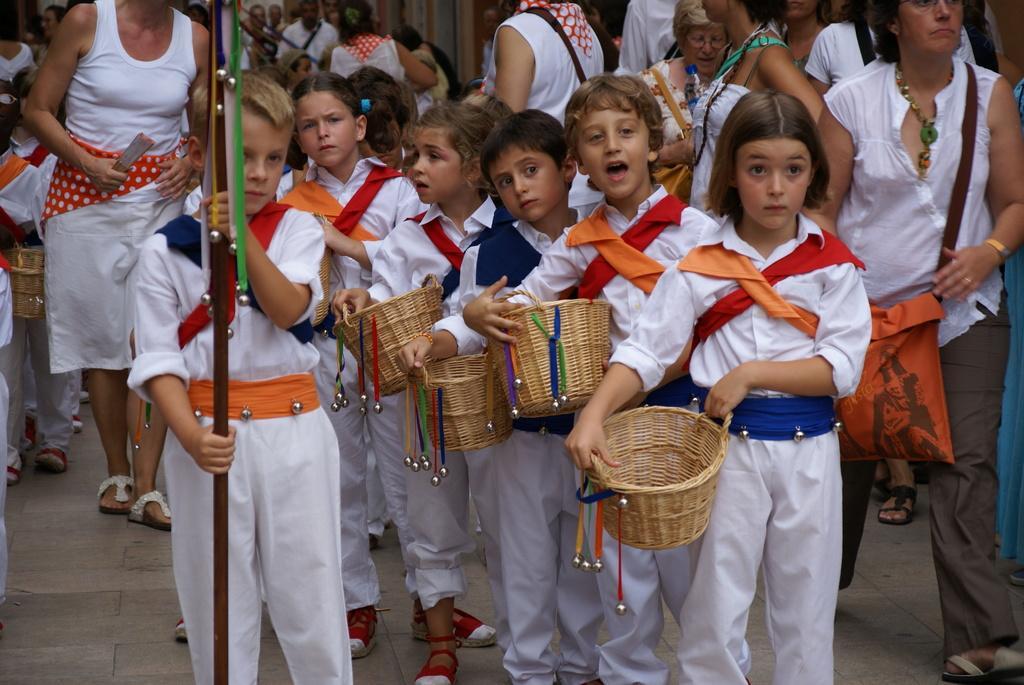Please provide a concise description of this image. In the image we can see there are many people and children standing and some of them are walking, they are wearing clothes and the children are holding a wooden basket in their hands. This is a flag, hand bag, footpath, shoes, neck chain and this is a bracelet. 